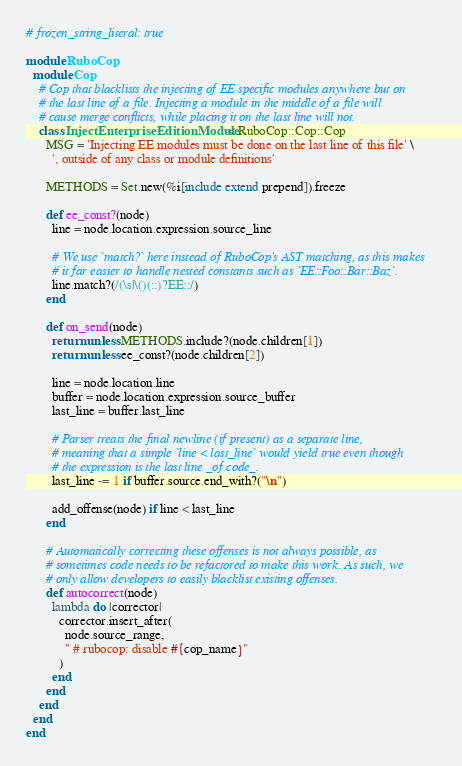<code> <loc_0><loc_0><loc_500><loc_500><_Ruby_># frozen_string_literal: true

module RuboCop
  module Cop
    # Cop that blacklists the injecting of EE specific modules anywhere but on
    # the last line of a file. Injecting a module in the middle of a file will
    # cause merge conflicts, while placing it on the last line will not.
    class InjectEnterpriseEditionModule < RuboCop::Cop::Cop
      MSG = 'Injecting EE modules must be done on the last line of this file' \
        ', outside of any class or module definitions'

      METHODS = Set.new(%i[include extend prepend]).freeze

      def ee_const?(node)
        line = node.location.expression.source_line

        # We use `match?` here instead of RuboCop's AST matching, as this makes
        # it far easier to handle nested constants such as `EE::Foo::Bar::Baz`.
        line.match?(/(\s|\()(::)?EE::/)
      end

      def on_send(node)
        return unless METHODS.include?(node.children[1])
        return unless ee_const?(node.children[2])

        line = node.location.line
        buffer = node.location.expression.source_buffer
        last_line = buffer.last_line

        # Parser treats the final newline (if present) as a separate line,
        # meaning that a simple `line < last_line` would yield true even though
        # the expression is the last line _of code_.
        last_line -= 1 if buffer.source.end_with?("\n")

        add_offense(node) if line < last_line
      end

      # Automatically correcting these offenses is not always possible, as
      # sometimes code needs to be refactored to make this work. As such, we
      # only allow developers to easily blacklist existing offenses.
      def autocorrect(node)
        lambda do |corrector|
          corrector.insert_after(
            node.source_range,
            " # rubocop: disable #{cop_name}"
          )
        end
      end
    end
  end
end
</code> 